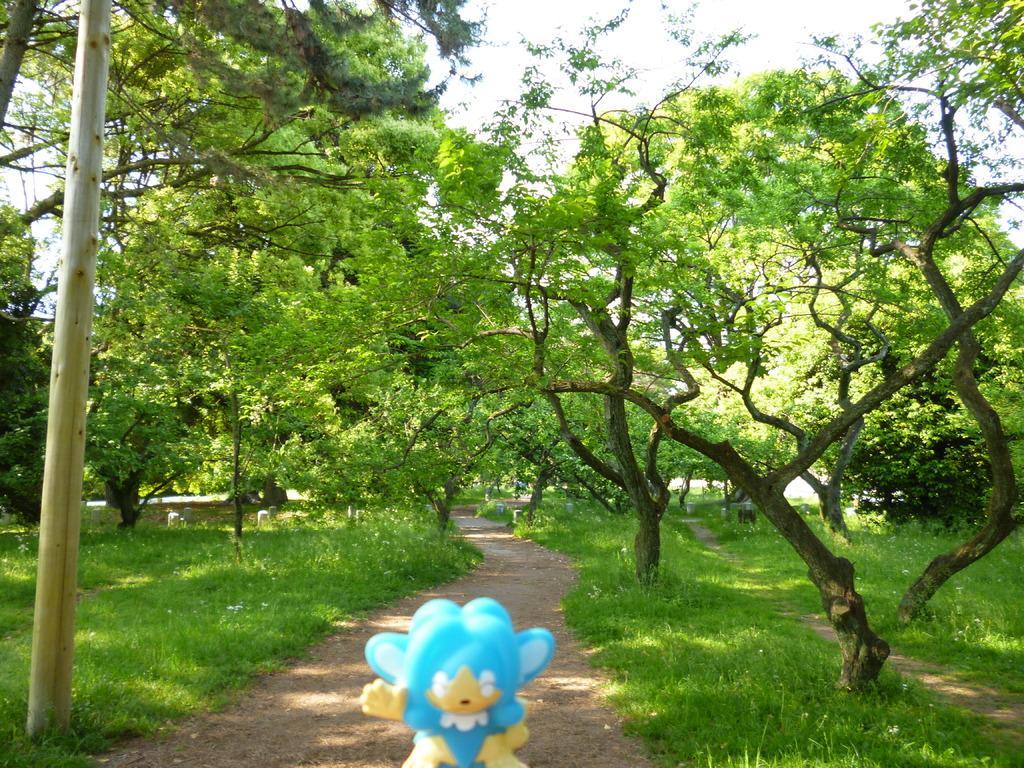Describe this image in one or two sentences. In the image there is a lot of grass and trees and in the foreground there is a toy. 